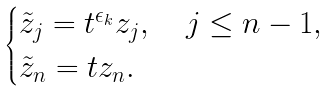<formula> <loc_0><loc_0><loc_500><loc_500>\begin{cases} \tilde { z } _ { j } = t ^ { \epsilon _ { k } } z _ { j } , \quad j \leq n - 1 , \\ \tilde { z } _ { n } = t z _ { n } . \end{cases}</formula> 